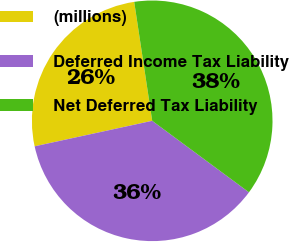<chart> <loc_0><loc_0><loc_500><loc_500><pie_chart><fcel>(millions)<fcel>Deferred Income Tax Liability<fcel>Net Deferred Tax Liability<nl><fcel>26.01%<fcel>36.47%<fcel>37.52%<nl></chart> 